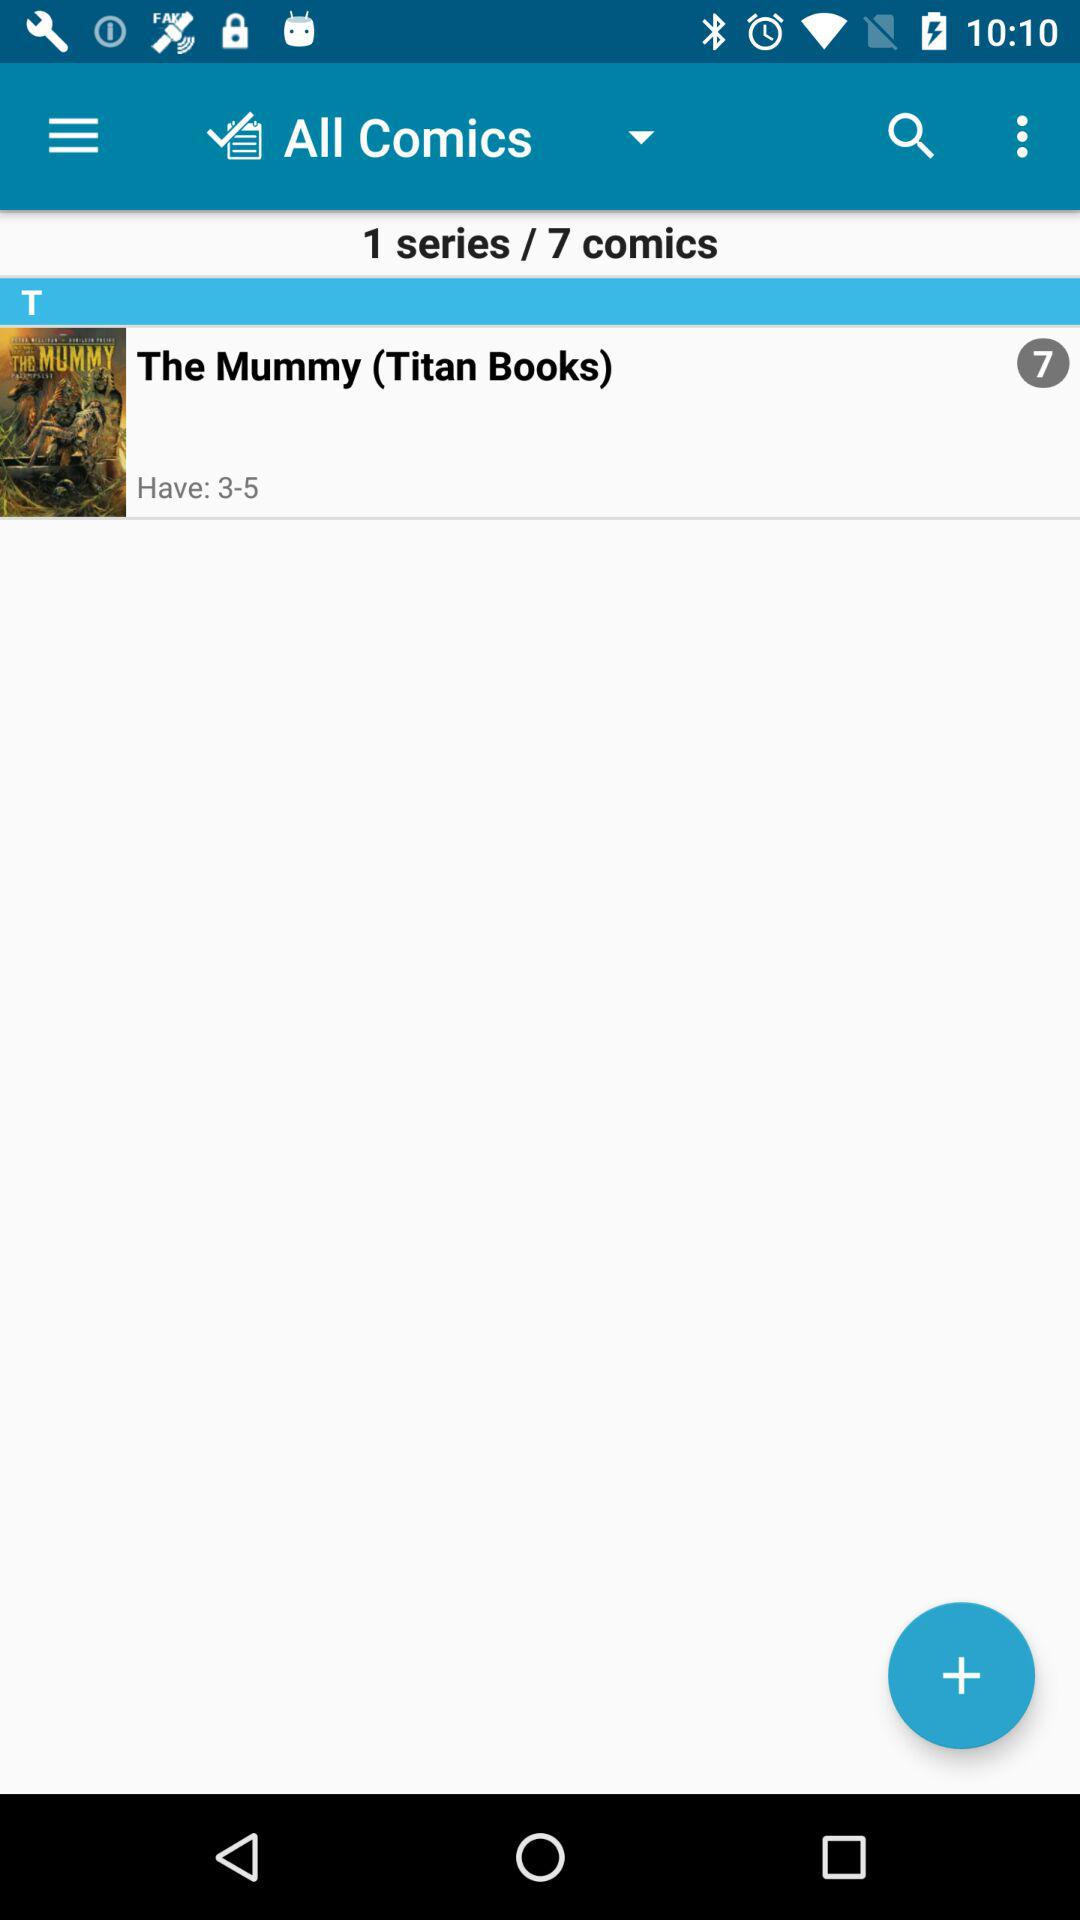What's the total number of Comics? The total number of comics is 7. 